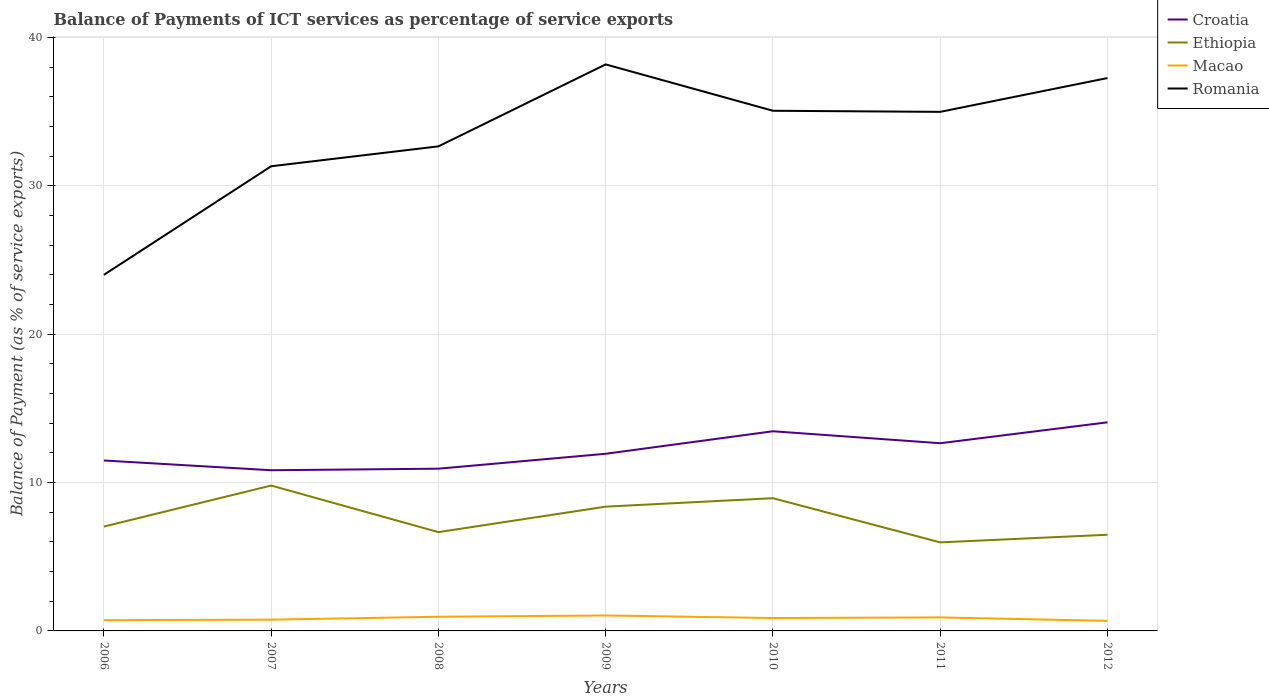How many different coloured lines are there?
Keep it short and to the point. 4. Does the line corresponding to Croatia intersect with the line corresponding to Romania?
Give a very brief answer. No. Across all years, what is the maximum balance of payments of ICT services in Ethiopia?
Make the answer very short. 5.97. What is the total balance of payments of ICT services in Croatia in the graph?
Provide a short and direct response. -0.71. What is the difference between the highest and the second highest balance of payments of ICT services in Macao?
Provide a succinct answer. 0.36. How many lines are there?
Your answer should be very brief. 4. How many years are there in the graph?
Ensure brevity in your answer.  7. What is the difference between two consecutive major ticks on the Y-axis?
Your answer should be compact. 10. Does the graph contain any zero values?
Keep it short and to the point. No. Does the graph contain grids?
Ensure brevity in your answer.  Yes. How are the legend labels stacked?
Provide a succinct answer. Vertical. What is the title of the graph?
Provide a short and direct response. Balance of Payments of ICT services as percentage of service exports. Does "Tanzania" appear as one of the legend labels in the graph?
Ensure brevity in your answer.  No. What is the label or title of the Y-axis?
Your answer should be very brief. Balance of Payment (as % of service exports). What is the Balance of Payment (as % of service exports) in Croatia in 2006?
Provide a short and direct response. 11.49. What is the Balance of Payment (as % of service exports) of Ethiopia in 2006?
Offer a terse response. 7.04. What is the Balance of Payment (as % of service exports) of Macao in 2006?
Offer a terse response. 0.72. What is the Balance of Payment (as % of service exports) in Romania in 2006?
Your response must be concise. 24.01. What is the Balance of Payment (as % of service exports) in Croatia in 2007?
Offer a terse response. 10.83. What is the Balance of Payment (as % of service exports) of Ethiopia in 2007?
Your response must be concise. 9.8. What is the Balance of Payment (as % of service exports) of Macao in 2007?
Provide a succinct answer. 0.76. What is the Balance of Payment (as % of service exports) of Romania in 2007?
Keep it short and to the point. 31.33. What is the Balance of Payment (as % of service exports) in Croatia in 2008?
Keep it short and to the point. 10.94. What is the Balance of Payment (as % of service exports) of Ethiopia in 2008?
Your answer should be compact. 6.66. What is the Balance of Payment (as % of service exports) of Macao in 2008?
Offer a very short reply. 0.96. What is the Balance of Payment (as % of service exports) of Romania in 2008?
Offer a very short reply. 32.67. What is the Balance of Payment (as % of service exports) in Croatia in 2009?
Provide a short and direct response. 11.94. What is the Balance of Payment (as % of service exports) of Ethiopia in 2009?
Keep it short and to the point. 8.38. What is the Balance of Payment (as % of service exports) in Macao in 2009?
Your answer should be very brief. 1.04. What is the Balance of Payment (as % of service exports) in Romania in 2009?
Make the answer very short. 38.2. What is the Balance of Payment (as % of service exports) in Croatia in 2010?
Give a very brief answer. 13.46. What is the Balance of Payment (as % of service exports) of Ethiopia in 2010?
Offer a very short reply. 8.95. What is the Balance of Payment (as % of service exports) of Macao in 2010?
Offer a terse response. 0.87. What is the Balance of Payment (as % of service exports) of Romania in 2010?
Make the answer very short. 35.07. What is the Balance of Payment (as % of service exports) in Croatia in 2011?
Give a very brief answer. 12.66. What is the Balance of Payment (as % of service exports) in Ethiopia in 2011?
Offer a terse response. 5.97. What is the Balance of Payment (as % of service exports) in Macao in 2011?
Your response must be concise. 0.91. What is the Balance of Payment (as % of service exports) in Romania in 2011?
Offer a terse response. 35. What is the Balance of Payment (as % of service exports) in Croatia in 2012?
Make the answer very short. 14.06. What is the Balance of Payment (as % of service exports) in Ethiopia in 2012?
Your answer should be compact. 6.48. What is the Balance of Payment (as % of service exports) of Macao in 2012?
Offer a very short reply. 0.68. What is the Balance of Payment (as % of service exports) of Romania in 2012?
Offer a terse response. 37.28. Across all years, what is the maximum Balance of Payment (as % of service exports) in Croatia?
Keep it short and to the point. 14.06. Across all years, what is the maximum Balance of Payment (as % of service exports) of Ethiopia?
Offer a terse response. 9.8. Across all years, what is the maximum Balance of Payment (as % of service exports) in Macao?
Provide a short and direct response. 1.04. Across all years, what is the maximum Balance of Payment (as % of service exports) of Romania?
Provide a short and direct response. 38.2. Across all years, what is the minimum Balance of Payment (as % of service exports) of Croatia?
Your response must be concise. 10.83. Across all years, what is the minimum Balance of Payment (as % of service exports) of Ethiopia?
Your answer should be very brief. 5.97. Across all years, what is the minimum Balance of Payment (as % of service exports) of Macao?
Ensure brevity in your answer.  0.68. Across all years, what is the minimum Balance of Payment (as % of service exports) in Romania?
Keep it short and to the point. 24.01. What is the total Balance of Payment (as % of service exports) of Croatia in the graph?
Your answer should be very brief. 85.39. What is the total Balance of Payment (as % of service exports) of Ethiopia in the graph?
Provide a succinct answer. 53.28. What is the total Balance of Payment (as % of service exports) of Macao in the graph?
Keep it short and to the point. 5.94. What is the total Balance of Payment (as % of service exports) of Romania in the graph?
Offer a terse response. 233.55. What is the difference between the Balance of Payment (as % of service exports) of Croatia in 2006 and that in 2007?
Provide a succinct answer. 0.66. What is the difference between the Balance of Payment (as % of service exports) of Ethiopia in 2006 and that in 2007?
Your answer should be very brief. -2.76. What is the difference between the Balance of Payment (as % of service exports) of Macao in 2006 and that in 2007?
Offer a terse response. -0.04. What is the difference between the Balance of Payment (as % of service exports) in Romania in 2006 and that in 2007?
Offer a very short reply. -7.32. What is the difference between the Balance of Payment (as % of service exports) of Croatia in 2006 and that in 2008?
Your answer should be compact. 0.55. What is the difference between the Balance of Payment (as % of service exports) in Ethiopia in 2006 and that in 2008?
Ensure brevity in your answer.  0.38. What is the difference between the Balance of Payment (as % of service exports) of Macao in 2006 and that in 2008?
Provide a succinct answer. -0.23. What is the difference between the Balance of Payment (as % of service exports) in Romania in 2006 and that in 2008?
Your response must be concise. -8.66. What is the difference between the Balance of Payment (as % of service exports) of Croatia in 2006 and that in 2009?
Offer a terse response. -0.45. What is the difference between the Balance of Payment (as % of service exports) in Ethiopia in 2006 and that in 2009?
Provide a succinct answer. -1.34. What is the difference between the Balance of Payment (as % of service exports) in Macao in 2006 and that in 2009?
Provide a succinct answer. -0.32. What is the difference between the Balance of Payment (as % of service exports) in Romania in 2006 and that in 2009?
Provide a short and direct response. -14.19. What is the difference between the Balance of Payment (as % of service exports) in Croatia in 2006 and that in 2010?
Ensure brevity in your answer.  -1.97. What is the difference between the Balance of Payment (as % of service exports) of Ethiopia in 2006 and that in 2010?
Your answer should be compact. -1.91. What is the difference between the Balance of Payment (as % of service exports) of Macao in 2006 and that in 2010?
Your response must be concise. -0.15. What is the difference between the Balance of Payment (as % of service exports) in Romania in 2006 and that in 2010?
Provide a short and direct response. -11.06. What is the difference between the Balance of Payment (as % of service exports) of Croatia in 2006 and that in 2011?
Offer a very short reply. -1.16. What is the difference between the Balance of Payment (as % of service exports) in Ethiopia in 2006 and that in 2011?
Your response must be concise. 1.07. What is the difference between the Balance of Payment (as % of service exports) in Macao in 2006 and that in 2011?
Your response must be concise. -0.19. What is the difference between the Balance of Payment (as % of service exports) of Romania in 2006 and that in 2011?
Give a very brief answer. -10.99. What is the difference between the Balance of Payment (as % of service exports) of Croatia in 2006 and that in 2012?
Provide a short and direct response. -2.57. What is the difference between the Balance of Payment (as % of service exports) in Ethiopia in 2006 and that in 2012?
Offer a terse response. 0.55. What is the difference between the Balance of Payment (as % of service exports) of Macao in 2006 and that in 2012?
Give a very brief answer. 0.05. What is the difference between the Balance of Payment (as % of service exports) in Romania in 2006 and that in 2012?
Provide a short and direct response. -13.27. What is the difference between the Balance of Payment (as % of service exports) of Croatia in 2007 and that in 2008?
Your response must be concise. -0.1. What is the difference between the Balance of Payment (as % of service exports) in Ethiopia in 2007 and that in 2008?
Your response must be concise. 3.14. What is the difference between the Balance of Payment (as % of service exports) in Macao in 2007 and that in 2008?
Your answer should be very brief. -0.2. What is the difference between the Balance of Payment (as % of service exports) in Romania in 2007 and that in 2008?
Provide a succinct answer. -1.34. What is the difference between the Balance of Payment (as % of service exports) in Croatia in 2007 and that in 2009?
Your answer should be compact. -1.11. What is the difference between the Balance of Payment (as % of service exports) in Ethiopia in 2007 and that in 2009?
Provide a succinct answer. 1.42. What is the difference between the Balance of Payment (as % of service exports) in Macao in 2007 and that in 2009?
Keep it short and to the point. -0.28. What is the difference between the Balance of Payment (as % of service exports) of Romania in 2007 and that in 2009?
Provide a short and direct response. -6.87. What is the difference between the Balance of Payment (as % of service exports) of Croatia in 2007 and that in 2010?
Ensure brevity in your answer.  -2.63. What is the difference between the Balance of Payment (as % of service exports) in Ethiopia in 2007 and that in 2010?
Ensure brevity in your answer.  0.85. What is the difference between the Balance of Payment (as % of service exports) in Macao in 2007 and that in 2010?
Keep it short and to the point. -0.11. What is the difference between the Balance of Payment (as % of service exports) in Romania in 2007 and that in 2010?
Offer a very short reply. -3.74. What is the difference between the Balance of Payment (as % of service exports) in Croatia in 2007 and that in 2011?
Provide a succinct answer. -1.82. What is the difference between the Balance of Payment (as % of service exports) of Ethiopia in 2007 and that in 2011?
Your answer should be very brief. 3.83. What is the difference between the Balance of Payment (as % of service exports) in Macao in 2007 and that in 2011?
Make the answer very short. -0.15. What is the difference between the Balance of Payment (as % of service exports) in Romania in 2007 and that in 2011?
Make the answer very short. -3.67. What is the difference between the Balance of Payment (as % of service exports) in Croatia in 2007 and that in 2012?
Give a very brief answer. -3.23. What is the difference between the Balance of Payment (as % of service exports) of Ethiopia in 2007 and that in 2012?
Your response must be concise. 3.32. What is the difference between the Balance of Payment (as % of service exports) in Macao in 2007 and that in 2012?
Offer a terse response. 0.08. What is the difference between the Balance of Payment (as % of service exports) in Romania in 2007 and that in 2012?
Provide a short and direct response. -5.95. What is the difference between the Balance of Payment (as % of service exports) of Croatia in 2008 and that in 2009?
Ensure brevity in your answer.  -1.01. What is the difference between the Balance of Payment (as % of service exports) of Ethiopia in 2008 and that in 2009?
Keep it short and to the point. -1.72. What is the difference between the Balance of Payment (as % of service exports) in Macao in 2008 and that in 2009?
Offer a terse response. -0.09. What is the difference between the Balance of Payment (as % of service exports) of Romania in 2008 and that in 2009?
Offer a very short reply. -5.53. What is the difference between the Balance of Payment (as % of service exports) in Croatia in 2008 and that in 2010?
Offer a terse response. -2.52. What is the difference between the Balance of Payment (as % of service exports) in Ethiopia in 2008 and that in 2010?
Make the answer very short. -2.29. What is the difference between the Balance of Payment (as % of service exports) in Macao in 2008 and that in 2010?
Offer a terse response. 0.09. What is the difference between the Balance of Payment (as % of service exports) in Romania in 2008 and that in 2010?
Your response must be concise. -2.4. What is the difference between the Balance of Payment (as % of service exports) in Croatia in 2008 and that in 2011?
Your answer should be very brief. -1.72. What is the difference between the Balance of Payment (as % of service exports) in Ethiopia in 2008 and that in 2011?
Offer a very short reply. 0.69. What is the difference between the Balance of Payment (as % of service exports) in Macao in 2008 and that in 2011?
Your response must be concise. 0.04. What is the difference between the Balance of Payment (as % of service exports) of Romania in 2008 and that in 2011?
Keep it short and to the point. -2.33. What is the difference between the Balance of Payment (as % of service exports) in Croatia in 2008 and that in 2012?
Your answer should be compact. -3.13. What is the difference between the Balance of Payment (as % of service exports) in Ethiopia in 2008 and that in 2012?
Offer a terse response. 0.18. What is the difference between the Balance of Payment (as % of service exports) of Macao in 2008 and that in 2012?
Your answer should be very brief. 0.28. What is the difference between the Balance of Payment (as % of service exports) in Romania in 2008 and that in 2012?
Keep it short and to the point. -4.61. What is the difference between the Balance of Payment (as % of service exports) in Croatia in 2009 and that in 2010?
Your response must be concise. -1.52. What is the difference between the Balance of Payment (as % of service exports) of Ethiopia in 2009 and that in 2010?
Offer a very short reply. -0.57. What is the difference between the Balance of Payment (as % of service exports) of Macao in 2009 and that in 2010?
Your answer should be very brief. 0.17. What is the difference between the Balance of Payment (as % of service exports) of Romania in 2009 and that in 2010?
Offer a very short reply. 3.13. What is the difference between the Balance of Payment (as % of service exports) in Croatia in 2009 and that in 2011?
Provide a short and direct response. -0.71. What is the difference between the Balance of Payment (as % of service exports) of Ethiopia in 2009 and that in 2011?
Ensure brevity in your answer.  2.41. What is the difference between the Balance of Payment (as % of service exports) of Macao in 2009 and that in 2011?
Keep it short and to the point. 0.13. What is the difference between the Balance of Payment (as % of service exports) in Romania in 2009 and that in 2011?
Ensure brevity in your answer.  3.2. What is the difference between the Balance of Payment (as % of service exports) in Croatia in 2009 and that in 2012?
Keep it short and to the point. -2.12. What is the difference between the Balance of Payment (as % of service exports) in Ethiopia in 2009 and that in 2012?
Ensure brevity in your answer.  1.89. What is the difference between the Balance of Payment (as % of service exports) in Macao in 2009 and that in 2012?
Give a very brief answer. 0.36. What is the difference between the Balance of Payment (as % of service exports) of Romania in 2009 and that in 2012?
Make the answer very short. 0.92. What is the difference between the Balance of Payment (as % of service exports) in Croatia in 2010 and that in 2011?
Your response must be concise. 0.81. What is the difference between the Balance of Payment (as % of service exports) in Ethiopia in 2010 and that in 2011?
Your answer should be very brief. 2.98. What is the difference between the Balance of Payment (as % of service exports) of Macao in 2010 and that in 2011?
Your response must be concise. -0.04. What is the difference between the Balance of Payment (as % of service exports) in Romania in 2010 and that in 2011?
Provide a short and direct response. 0.07. What is the difference between the Balance of Payment (as % of service exports) in Croatia in 2010 and that in 2012?
Offer a very short reply. -0.6. What is the difference between the Balance of Payment (as % of service exports) of Ethiopia in 2010 and that in 2012?
Give a very brief answer. 2.46. What is the difference between the Balance of Payment (as % of service exports) of Macao in 2010 and that in 2012?
Provide a short and direct response. 0.19. What is the difference between the Balance of Payment (as % of service exports) in Romania in 2010 and that in 2012?
Your response must be concise. -2.21. What is the difference between the Balance of Payment (as % of service exports) in Croatia in 2011 and that in 2012?
Provide a short and direct response. -1.41. What is the difference between the Balance of Payment (as % of service exports) in Ethiopia in 2011 and that in 2012?
Offer a very short reply. -0.51. What is the difference between the Balance of Payment (as % of service exports) of Macao in 2011 and that in 2012?
Provide a succinct answer. 0.23. What is the difference between the Balance of Payment (as % of service exports) in Romania in 2011 and that in 2012?
Your answer should be compact. -2.28. What is the difference between the Balance of Payment (as % of service exports) of Croatia in 2006 and the Balance of Payment (as % of service exports) of Ethiopia in 2007?
Give a very brief answer. 1.69. What is the difference between the Balance of Payment (as % of service exports) of Croatia in 2006 and the Balance of Payment (as % of service exports) of Macao in 2007?
Provide a short and direct response. 10.73. What is the difference between the Balance of Payment (as % of service exports) of Croatia in 2006 and the Balance of Payment (as % of service exports) of Romania in 2007?
Give a very brief answer. -19.84. What is the difference between the Balance of Payment (as % of service exports) of Ethiopia in 2006 and the Balance of Payment (as % of service exports) of Macao in 2007?
Your answer should be very brief. 6.28. What is the difference between the Balance of Payment (as % of service exports) of Ethiopia in 2006 and the Balance of Payment (as % of service exports) of Romania in 2007?
Offer a terse response. -24.29. What is the difference between the Balance of Payment (as % of service exports) of Macao in 2006 and the Balance of Payment (as % of service exports) of Romania in 2007?
Your answer should be compact. -30.61. What is the difference between the Balance of Payment (as % of service exports) of Croatia in 2006 and the Balance of Payment (as % of service exports) of Ethiopia in 2008?
Provide a succinct answer. 4.83. What is the difference between the Balance of Payment (as % of service exports) in Croatia in 2006 and the Balance of Payment (as % of service exports) in Macao in 2008?
Your answer should be very brief. 10.54. What is the difference between the Balance of Payment (as % of service exports) in Croatia in 2006 and the Balance of Payment (as % of service exports) in Romania in 2008?
Provide a short and direct response. -21.18. What is the difference between the Balance of Payment (as % of service exports) of Ethiopia in 2006 and the Balance of Payment (as % of service exports) of Macao in 2008?
Offer a very short reply. 6.08. What is the difference between the Balance of Payment (as % of service exports) of Ethiopia in 2006 and the Balance of Payment (as % of service exports) of Romania in 2008?
Make the answer very short. -25.63. What is the difference between the Balance of Payment (as % of service exports) in Macao in 2006 and the Balance of Payment (as % of service exports) in Romania in 2008?
Your answer should be very brief. -31.95. What is the difference between the Balance of Payment (as % of service exports) in Croatia in 2006 and the Balance of Payment (as % of service exports) in Ethiopia in 2009?
Provide a short and direct response. 3.11. What is the difference between the Balance of Payment (as % of service exports) of Croatia in 2006 and the Balance of Payment (as % of service exports) of Macao in 2009?
Your answer should be compact. 10.45. What is the difference between the Balance of Payment (as % of service exports) of Croatia in 2006 and the Balance of Payment (as % of service exports) of Romania in 2009?
Make the answer very short. -26.71. What is the difference between the Balance of Payment (as % of service exports) in Ethiopia in 2006 and the Balance of Payment (as % of service exports) in Macao in 2009?
Offer a terse response. 5.99. What is the difference between the Balance of Payment (as % of service exports) of Ethiopia in 2006 and the Balance of Payment (as % of service exports) of Romania in 2009?
Your answer should be very brief. -31.16. What is the difference between the Balance of Payment (as % of service exports) in Macao in 2006 and the Balance of Payment (as % of service exports) in Romania in 2009?
Keep it short and to the point. -37.47. What is the difference between the Balance of Payment (as % of service exports) in Croatia in 2006 and the Balance of Payment (as % of service exports) in Ethiopia in 2010?
Give a very brief answer. 2.54. What is the difference between the Balance of Payment (as % of service exports) in Croatia in 2006 and the Balance of Payment (as % of service exports) in Macao in 2010?
Offer a very short reply. 10.62. What is the difference between the Balance of Payment (as % of service exports) of Croatia in 2006 and the Balance of Payment (as % of service exports) of Romania in 2010?
Your response must be concise. -23.58. What is the difference between the Balance of Payment (as % of service exports) of Ethiopia in 2006 and the Balance of Payment (as % of service exports) of Macao in 2010?
Your response must be concise. 6.17. What is the difference between the Balance of Payment (as % of service exports) of Ethiopia in 2006 and the Balance of Payment (as % of service exports) of Romania in 2010?
Your answer should be compact. -28.03. What is the difference between the Balance of Payment (as % of service exports) in Macao in 2006 and the Balance of Payment (as % of service exports) in Romania in 2010?
Make the answer very short. -34.35. What is the difference between the Balance of Payment (as % of service exports) of Croatia in 2006 and the Balance of Payment (as % of service exports) of Ethiopia in 2011?
Offer a very short reply. 5.52. What is the difference between the Balance of Payment (as % of service exports) in Croatia in 2006 and the Balance of Payment (as % of service exports) in Macao in 2011?
Provide a short and direct response. 10.58. What is the difference between the Balance of Payment (as % of service exports) of Croatia in 2006 and the Balance of Payment (as % of service exports) of Romania in 2011?
Give a very brief answer. -23.51. What is the difference between the Balance of Payment (as % of service exports) of Ethiopia in 2006 and the Balance of Payment (as % of service exports) of Macao in 2011?
Provide a short and direct response. 6.13. What is the difference between the Balance of Payment (as % of service exports) of Ethiopia in 2006 and the Balance of Payment (as % of service exports) of Romania in 2011?
Ensure brevity in your answer.  -27.96. What is the difference between the Balance of Payment (as % of service exports) in Macao in 2006 and the Balance of Payment (as % of service exports) in Romania in 2011?
Your answer should be compact. -34.27. What is the difference between the Balance of Payment (as % of service exports) of Croatia in 2006 and the Balance of Payment (as % of service exports) of Ethiopia in 2012?
Your response must be concise. 5.01. What is the difference between the Balance of Payment (as % of service exports) of Croatia in 2006 and the Balance of Payment (as % of service exports) of Macao in 2012?
Ensure brevity in your answer.  10.81. What is the difference between the Balance of Payment (as % of service exports) in Croatia in 2006 and the Balance of Payment (as % of service exports) in Romania in 2012?
Provide a succinct answer. -25.79. What is the difference between the Balance of Payment (as % of service exports) in Ethiopia in 2006 and the Balance of Payment (as % of service exports) in Macao in 2012?
Your answer should be compact. 6.36. What is the difference between the Balance of Payment (as % of service exports) in Ethiopia in 2006 and the Balance of Payment (as % of service exports) in Romania in 2012?
Offer a terse response. -30.24. What is the difference between the Balance of Payment (as % of service exports) in Macao in 2006 and the Balance of Payment (as % of service exports) in Romania in 2012?
Your answer should be compact. -36.55. What is the difference between the Balance of Payment (as % of service exports) of Croatia in 2007 and the Balance of Payment (as % of service exports) of Ethiopia in 2008?
Your answer should be very brief. 4.17. What is the difference between the Balance of Payment (as % of service exports) of Croatia in 2007 and the Balance of Payment (as % of service exports) of Macao in 2008?
Your response must be concise. 9.88. What is the difference between the Balance of Payment (as % of service exports) in Croatia in 2007 and the Balance of Payment (as % of service exports) in Romania in 2008?
Your answer should be very brief. -21.84. What is the difference between the Balance of Payment (as % of service exports) in Ethiopia in 2007 and the Balance of Payment (as % of service exports) in Macao in 2008?
Give a very brief answer. 8.85. What is the difference between the Balance of Payment (as % of service exports) in Ethiopia in 2007 and the Balance of Payment (as % of service exports) in Romania in 2008?
Your answer should be very brief. -22.87. What is the difference between the Balance of Payment (as % of service exports) of Macao in 2007 and the Balance of Payment (as % of service exports) of Romania in 2008?
Your answer should be very brief. -31.91. What is the difference between the Balance of Payment (as % of service exports) in Croatia in 2007 and the Balance of Payment (as % of service exports) in Ethiopia in 2009?
Make the answer very short. 2.46. What is the difference between the Balance of Payment (as % of service exports) in Croatia in 2007 and the Balance of Payment (as % of service exports) in Macao in 2009?
Your answer should be very brief. 9.79. What is the difference between the Balance of Payment (as % of service exports) in Croatia in 2007 and the Balance of Payment (as % of service exports) in Romania in 2009?
Your answer should be compact. -27.36. What is the difference between the Balance of Payment (as % of service exports) of Ethiopia in 2007 and the Balance of Payment (as % of service exports) of Macao in 2009?
Offer a terse response. 8.76. What is the difference between the Balance of Payment (as % of service exports) of Ethiopia in 2007 and the Balance of Payment (as % of service exports) of Romania in 2009?
Your response must be concise. -28.39. What is the difference between the Balance of Payment (as % of service exports) of Macao in 2007 and the Balance of Payment (as % of service exports) of Romania in 2009?
Your answer should be very brief. -37.44. What is the difference between the Balance of Payment (as % of service exports) in Croatia in 2007 and the Balance of Payment (as % of service exports) in Ethiopia in 2010?
Ensure brevity in your answer.  1.89. What is the difference between the Balance of Payment (as % of service exports) of Croatia in 2007 and the Balance of Payment (as % of service exports) of Macao in 2010?
Your response must be concise. 9.97. What is the difference between the Balance of Payment (as % of service exports) of Croatia in 2007 and the Balance of Payment (as % of service exports) of Romania in 2010?
Your answer should be very brief. -24.24. What is the difference between the Balance of Payment (as % of service exports) of Ethiopia in 2007 and the Balance of Payment (as % of service exports) of Macao in 2010?
Give a very brief answer. 8.93. What is the difference between the Balance of Payment (as % of service exports) of Ethiopia in 2007 and the Balance of Payment (as % of service exports) of Romania in 2010?
Keep it short and to the point. -25.27. What is the difference between the Balance of Payment (as % of service exports) in Macao in 2007 and the Balance of Payment (as % of service exports) in Romania in 2010?
Keep it short and to the point. -34.31. What is the difference between the Balance of Payment (as % of service exports) of Croatia in 2007 and the Balance of Payment (as % of service exports) of Ethiopia in 2011?
Make the answer very short. 4.86. What is the difference between the Balance of Payment (as % of service exports) in Croatia in 2007 and the Balance of Payment (as % of service exports) in Macao in 2011?
Make the answer very short. 9.92. What is the difference between the Balance of Payment (as % of service exports) in Croatia in 2007 and the Balance of Payment (as % of service exports) in Romania in 2011?
Provide a succinct answer. -24.16. What is the difference between the Balance of Payment (as % of service exports) in Ethiopia in 2007 and the Balance of Payment (as % of service exports) in Macao in 2011?
Provide a short and direct response. 8.89. What is the difference between the Balance of Payment (as % of service exports) in Ethiopia in 2007 and the Balance of Payment (as % of service exports) in Romania in 2011?
Your answer should be compact. -25.2. What is the difference between the Balance of Payment (as % of service exports) in Macao in 2007 and the Balance of Payment (as % of service exports) in Romania in 2011?
Your answer should be compact. -34.24. What is the difference between the Balance of Payment (as % of service exports) in Croatia in 2007 and the Balance of Payment (as % of service exports) in Ethiopia in 2012?
Keep it short and to the point. 4.35. What is the difference between the Balance of Payment (as % of service exports) in Croatia in 2007 and the Balance of Payment (as % of service exports) in Macao in 2012?
Ensure brevity in your answer.  10.16. What is the difference between the Balance of Payment (as % of service exports) in Croatia in 2007 and the Balance of Payment (as % of service exports) in Romania in 2012?
Your answer should be very brief. -26.44. What is the difference between the Balance of Payment (as % of service exports) of Ethiopia in 2007 and the Balance of Payment (as % of service exports) of Macao in 2012?
Provide a succinct answer. 9.12. What is the difference between the Balance of Payment (as % of service exports) in Ethiopia in 2007 and the Balance of Payment (as % of service exports) in Romania in 2012?
Your response must be concise. -27.47. What is the difference between the Balance of Payment (as % of service exports) of Macao in 2007 and the Balance of Payment (as % of service exports) of Romania in 2012?
Your answer should be compact. -36.52. What is the difference between the Balance of Payment (as % of service exports) in Croatia in 2008 and the Balance of Payment (as % of service exports) in Ethiopia in 2009?
Your response must be concise. 2.56. What is the difference between the Balance of Payment (as % of service exports) in Croatia in 2008 and the Balance of Payment (as % of service exports) in Macao in 2009?
Provide a short and direct response. 9.89. What is the difference between the Balance of Payment (as % of service exports) of Croatia in 2008 and the Balance of Payment (as % of service exports) of Romania in 2009?
Ensure brevity in your answer.  -27.26. What is the difference between the Balance of Payment (as % of service exports) of Ethiopia in 2008 and the Balance of Payment (as % of service exports) of Macao in 2009?
Make the answer very short. 5.62. What is the difference between the Balance of Payment (as % of service exports) in Ethiopia in 2008 and the Balance of Payment (as % of service exports) in Romania in 2009?
Keep it short and to the point. -31.54. What is the difference between the Balance of Payment (as % of service exports) of Macao in 2008 and the Balance of Payment (as % of service exports) of Romania in 2009?
Your response must be concise. -37.24. What is the difference between the Balance of Payment (as % of service exports) in Croatia in 2008 and the Balance of Payment (as % of service exports) in Ethiopia in 2010?
Make the answer very short. 1.99. What is the difference between the Balance of Payment (as % of service exports) in Croatia in 2008 and the Balance of Payment (as % of service exports) in Macao in 2010?
Ensure brevity in your answer.  10.07. What is the difference between the Balance of Payment (as % of service exports) of Croatia in 2008 and the Balance of Payment (as % of service exports) of Romania in 2010?
Your answer should be compact. -24.13. What is the difference between the Balance of Payment (as % of service exports) in Ethiopia in 2008 and the Balance of Payment (as % of service exports) in Macao in 2010?
Your answer should be compact. 5.79. What is the difference between the Balance of Payment (as % of service exports) of Ethiopia in 2008 and the Balance of Payment (as % of service exports) of Romania in 2010?
Your answer should be compact. -28.41. What is the difference between the Balance of Payment (as % of service exports) of Macao in 2008 and the Balance of Payment (as % of service exports) of Romania in 2010?
Offer a terse response. -34.11. What is the difference between the Balance of Payment (as % of service exports) in Croatia in 2008 and the Balance of Payment (as % of service exports) in Ethiopia in 2011?
Give a very brief answer. 4.97. What is the difference between the Balance of Payment (as % of service exports) in Croatia in 2008 and the Balance of Payment (as % of service exports) in Macao in 2011?
Provide a short and direct response. 10.03. What is the difference between the Balance of Payment (as % of service exports) of Croatia in 2008 and the Balance of Payment (as % of service exports) of Romania in 2011?
Your answer should be compact. -24.06. What is the difference between the Balance of Payment (as % of service exports) of Ethiopia in 2008 and the Balance of Payment (as % of service exports) of Macao in 2011?
Your answer should be compact. 5.75. What is the difference between the Balance of Payment (as % of service exports) of Ethiopia in 2008 and the Balance of Payment (as % of service exports) of Romania in 2011?
Offer a terse response. -28.34. What is the difference between the Balance of Payment (as % of service exports) in Macao in 2008 and the Balance of Payment (as % of service exports) in Romania in 2011?
Offer a very short reply. -34.04. What is the difference between the Balance of Payment (as % of service exports) of Croatia in 2008 and the Balance of Payment (as % of service exports) of Ethiopia in 2012?
Provide a short and direct response. 4.45. What is the difference between the Balance of Payment (as % of service exports) in Croatia in 2008 and the Balance of Payment (as % of service exports) in Macao in 2012?
Make the answer very short. 10.26. What is the difference between the Balance of Payment (as % of service exports) of Croatia in 2008 and the Balance of Payment (as % of service exports) of Romania in 2012?
Ensure brevity in your answer.  -26.34. What is the difference between the Balance of Payment (as % of service exports) in Ethiopia in 2008 and the Balance of Payment (as % of service exports) in Macao in 2012?
Your answer should be very brief. 5.98. What is the difference between the Balance of Payment (as % of service exports) of Ethiopia in 2008 and the Balance of Payment (as % of service exports) of Romania in 2012?
Provide a succinct answer. -30.62. What is the difference between the Balance of Payment (as % of service exports) of Macao in 2008 and the Balance of Payment (as % of service exports) of Romania in 2012?
Your answer should be very brief. -36.32. What is the difference between the Balance of Payment (as % of service exports) in Croatia in 2009 and the Balance of Payment (as % of service exports) in Ethiopia in 2010?
Your answer should be very brief. 3. What is the difference between the Balance of Payment (as % of service exports) of Croatia in 2009 and the Balance of Payment (as % of service exports) of Macao in 2010?
Your answer should be very brief. 11.08. What is the difference between the Balance of Payment (as % of service exports) of Croatia in 2009 and the Balance of Payment (as % of service exports) of Romania in 2010?
Provide a succinct answer. -23.13. What is the difference between the Balance of Payment (as % of service exports) of Ethiopia in 2009 and the Balance of Payment (as % of service exports) of Macao in 2010?
Keep it short and to the point. 7.51. What is the difference between the Balance of Payment (as % of service exports) in Ethiopia in 2009 and the Balance of Payment (as % of service exports) in Romania in 2010?
Provide a short and direct response. -26.69. What is the difference between the Balance of Payment (as % of service exports) in Macao in 2009 and the Balance of Payment (as % of service exports) in Romania in 2010?
Make the answer very short. -34.03. What is the difference between the Balance of Payment (as % of service exports) in Croatia in 2009 and the Balance of Payment (as % of service exports) in Ethiopia in 2011?
Your answer should be very brief. 5.97. What is the difference between the Balance of Payment (as % of service exports) in Croatia in 2009 and the Balance of Payment (as % of service exports) in Macao in 2011?
Provide a short and direct response. 11.03. What is the difference between the Balance of Payment (as % of service exports) of Croatia in 2009 and the Balance of Payment (as % of service exports) of Romania in 2011?
Your answer should be compact. -23.05. What is the difference between the Balance of Payment (as % of service exports) in Ethiopia in 2009 and the Balance of Payment (as % of service exports) in Macao in 2011?
Provide a short and direct response. 7.47. What is the difference between the Balance of Payment (as % of service exports) in Ethiopia in 2009 and the Balance of Payment (as % of service exports) in Romania in 2011?
Your response must be concise. -26.62. What is the difference between the Balance of Payment (as % of service exports) of Macao in 2009 and the Balance of Payment (as % of service exports) of Romania in 2011?
Offer a terse response. -33.95. What is the difference between the Balance of Payment (as % of service exports) of Croatia in 2009 and the Balance of Payment (as % of service exports) of Ethiopia in 2012?
Offer a very short reply. 5.46. What is the difference between the Balance of Payment (as % of service exports) of Croatia in 2009 and the Balance of Payment (as % of service exports) of Macao in 2012?
Keep it short and to the point. 11.27. What is the difference between the Balance of Payment (as % of service exports) in Croatia in 2009 and the Balance of Payment (as % of service exports) in Romania in 2012?
Offer a terse response. -25.33. What is the difference between the Balance of Payment (as % of service exports) of Ethiopia in 2009 and the Balance of Payment (as % of service exports) of Romania in 2012?
Provide a short and direct response. -28.9. What is the difference between the Balance of Payment (as % of service exports) in Macao in 2009 and the Balance of Payment (as % of service exports) in Romania in 2012?
Provide a succinct answer. -36.23. What is the difference between the Balance of Payment (as % of service exports) of Croatia in 2010 and the Balance of Payment (as % of service exports) of Ethiopia in 2011?
Give a very brief answer. 7.49. What is the difference between the Balance of Payment (as % of service exports) in Croatia in 2010 and the Balance of Payment (as % of service exports) in Macao in 2011?
Keep it short and to the point. 12.55. What is the difference between the Balance of Payment (as % of service exports) of Croatia in 2010 and the Balance of Payment (as % of service exports) of Romania in 2011?
Give a very brief answer. -21.54. What is the difference between the Balance of Payment (as % of service exports) of Ethiopia in 2010 and the Balance of Payment (as % of service exports) of Macao in 2011?
Offer a terse response. 8.04. What is the difference between the Balance of Payment (as % of service exports) in Ethiopia in 2010 and the Balance of Payment (as % of service exports) in Romania in 2011?
Your answer should be compact. -26.05. What is the difference between the Balance of Payment (as % of service exports) in Macao in 2010 and the Balance of Payment (as % of service exports) in Romania in 2011?
Provide a short and direct response. -34.13. What is the difference between the Balance of Payment (as % of service exports) in Croatia in 2010 and the Balance of Payment (as % of service exports) in Ethiopia in 2012?
Ensure brevity in your answer.  6.98. What is the difference between the Balance of Payment (as % of service exports) of Croatia in 2010 and the Balance of Payment (as % of service exports) of Macao in 2012?
Provide a succinct answer. 12.78. What is the difference between the Balance of Payment (as % of service exports) of Croatia in 2010 and the Balance of Payment (as % of service exports) of Romania in 2012?
Your answer should be compact. -23.81. What is the difference between the Balance of Payment (as % of service exports) in Ethiopia in 2010 and the Balance of Payment (as % of service exports) in Macao in 2012?
Your answer should be very brief. 8.27. What is the difference between the Balance of Payment (as % of service exports) in Ethiopia in 2010 and the Balance of Payment (as % of service exports) in Romania in 2012?
Give a very brief answer. -28.33. What is the difference between the Balance of Payment (as % of service exports) of Macao in 2010 and the Balance of Payment (as % of service exports) of Romania in 2012?
Your answer should be very brief. -36.41. What is the difference between the Balance of Payment (as % of service exports) of Croatia in 2011 and the Balance of Payment (as % of service exports) of Ethiopia in 2012?
Ensure brevity in your answer.  6.17. What is the difference between the Balance of Payment (as % of service exports) in Croatia in 2011 and the Balance of Payment (as % of service exports) in Macao in 2012?
Provide a short and direct response. 11.98. What is the difference between the Balance of Payment (as % of service exports) of Croatia in 2011 and the Balance of Payment (as % of service exports) of Romania in 2012?
Offer a terse response. -24.62. What is the difference between the Balance of Payment (as % of service exports) of Ethiopia in 2011 and the Balance of Payment (as % of service exports) of Macao in 2012?
Provide a short and direct response. 5.29. What is the difference between the Balance of Payment (as % of service exports) in Ethiopia in 2011 and the Balance of Payment (as % of service exports) in Romania in 2012?
Provide a succinct answer. -31.31. What is the difference between the Balance of Payment (as % of service exports) of Macao in 2011 and the Balance of Payment (as % of service exports) of Romania in 2012?
Give a very brief answer. -36.37. What is the average Balance of Payment (as % of service exports) of Croatia per year?
Your answer should be very brief. 12.2. What is the average Balance of Payment (as % of service exports) in Ethiopia per year?
Your answer should be compact. 7.61. What is the average Balance of Payment (as % of service exports) of Macao per year?
Provide a short and direct response. 0.85. What is the average Balance of Payment (as % of service exports) of Romania per year?
Provide a succinct answer. 33.36. In the year 2006, what is the difference between the Balance of Payment (as % of service exports) of Croatia and Balance of Payment (as % of service exports) of Ethiopia?
Provide a short and direct response. 4.45. In the year 2006, what is the difference between the Balance of Payment (as % of service exports) of Croatia and Balance of Payment (as % of service exports) of Macao?
Offer a terse response. 10.77. In the year 2006, what is the difference between the Balance of Payment (as % of service exports) of Croatia and Balance of Payment (as % of service exports) of Romania?
Give a very brief answer. -12.52. In the year 2006, what is the difference between the Balance of Payment (as % of service exports) in Ethiopia and Balance of Payment (as % of service exports) in Macao?
Provide a succinct answer. 6.31. In the year 2006, what is the difference between the Balance of Payment (as % of service exports) in Ethiopia and Balance of Payment (as % of service exports) in Romania?
Keep it short and to the point. -16.97. In the year 2006, what is the difference between the Balance of Payment (as % of service exports) in Macao and Balance of Payment (as % of service exports) in Romania?
Your response must be concise. -23.28. In the year 2007, what is the difference between the Balance of Payment (as % of service exports) of Croatia and Balance of Payment (as % of service exports) of Ethiopia?
Provide a short and direct response. 1.03. In the year 2007, what is the difference between the Balance of Payment (as % of service exports) in Croatia and Balance of Payment (as % of service exports) in Macao?
Make the answer very short. 10.08. In the year 2007, what is the difference between the Balance of Payment (as % of service exports) in Croatia and Balance of Payment (as % of service exports) in Romania?
Your answer should be compact. -20.49. In the year 2007, what is the difference between the Balance of Payment (as % of service exports) in Ethiopia and Balance of Payment (as % of service exports) in Macao?
Give a very brief answer. 9.04. In the year 2007, what is the difference between the Balance of Payment (as % of service exports) in Ethiopia and Balance of Payment (as % of service exports) in Romania?
Provide a succinct answer. -21.53. In the year 2007, what is the difference between the Balance of Payment (as % of service exports) of Macao and Balance of Payment (as % of service exports) of Romania?
Provide a short and direct response. -30.57. In the year 2008, what is the difference between the Balance of Payment (as % of service exports) of Croatia and Balance of Payment (as % of service exports) of Ethiopia?
Your response must be concise. 4.28. In the year 2008, what is the difference between the Balance of Payment (as % of service exports) of Croatia and Balance of Payment (as % of service exports) of Macao?
Your response must be concise. 9.98. In the year 2008, what is the difference between the Balance of Payment (as % of service exports) in Croatia and Balance of Payment (as % of service exports) in Romania?
Offer a very short reply. -21.73. In the year 2008, what is the difference between the Balance of Payment (as % of service exports) of Ethiopia and Balance of Payment (as % of service exports) of Macao?
Your answer should be very brief. 5.7. In the year 2008, what is the difference between the Balance of Payment (as % of service exports) in Ethiopia and Balance of Payment (as % of service exports) in Romania?
Provide a short and direct response. -26.01. In the year 2008, what is the difference between the Balance of Payment (as % of service exports) of Macao and Balance of Payment (as % of service exports) of Romania?
Your answer should be compact. -31.71. In the year 2009, what is the difference between the Balance of Payment (as % of service exports) of Croatia and Balance of Payment (as % of service exports) of Ethiopia?
Offer a terse response. 3.57. In the year 2009, what is the difference between the Balance of Payment (as % of service exports) in Croatia and Balance of Payment (as % of service exports) in Macao?
Provide a short and direct response. 10.9. In the year 2009, what is the difference between the Balance of Payment (as % of service exports) in Croatia and Balance of Payment (as % of service exports) in Romania?
Make the answer very short. -26.25. In the year 2009, what is the difference between the Balance of Payment (as % of service exports) of Ethiopia and Balance of Payment (as % of service exports) of Macao?
Your answer should be very brief. 7.34. In the year 2009, what is the difference between the Balance of Payment (as % of service exports) of Ethiopia and Balance of Payment (as % of service exports) of Romania?
Make the answer very short. -29.82. In the year 2009, what is the difference between the Balance of Payment (as % of service exports) of Macao and Balance of Payment (as % of service exports) of Romania?
Offer a terse response. -37.15. In the year 2010, what is the difference between the Balance of Payment (as % of service exports) of Croatia and Balance of Payment (as % of service exports) of Ethiopia?
Your response must be concise. 4.51. In the year 2010, what is the difference between the Balance of Payment (as % of service exports) of Croatia and Balance of Payment (as % of service exports) of Macao?
Your answer should be compact. 12.59. In the year 2010, what is the difference between the Balance of Payment (as % of service exports) of Croatia and Balance of Payment (as % of service exports) of Romania?
Give a very brief answer. -21.61. In the year 2010, what is the difference between the Balance of Payment (as % of service exports) in Ethiopia and Balance of Payment (as % of service exports) in Macao?
Provide a succinct answer. 8.08. In the year 2010, what is the difference between the Balance of Payment (as % of service exports) in Ethiopia and Balance of Payment (as % of service exports) in Romania?
Your response must be concise. -26.12. In the year 2010, what is the difference between the Balance of Payment (as % of service exports) in Macao and Balance of Payment (as % of service exports) in Romania?
Keep it short and to the point. -34.2. In the year 2011, what is the difference between the Balance of Payment (as % of service exports) of Croatia and Balance of Payment (as % of service exports) of Ethiopia?
Your response must be concise. 6.68. In the year 2011, what is the difference between the Balance of Payment (as % of service exports) of Croatia and Balance of Payment (as % of service exports) of Macao?
Your answer should be very brief. 11.74. In the year 2011, what is the difference between the Balance of Payment (as % of service exports) of Croatia and Balance of Payment (as % of service exports) of Romania?
Provide a short and direct response. -22.34. In the year 2011, what is the difference between the Balance of Payment (as % of service exports) in Ethiopia and Balance of Payment (as % of service exports) in Macao?
Your answer should be compact. 5.06. In the year 2011, what is the difference between the Balance of Payment (as % of service exports) of Ethiopia and Balance of Payment (as % of service exports) of Romania?
Ensure brevity in your answer.  -29.03. In the year 2011, what is the difference between the Balance of Payment (as % of service exports) in Macao and Balance of Payment (as % of service exports) in Romania?
Provide a succinct answer. -34.09. In the year 2012, what is the difference between the Balance of Payment (as % of service exports) of Croatia and Balance of Payment (as % of service exports) of Ethiopia?
Provide a short and direct response. 7.58. In the year 2012, what is the difference between the Balance of Payment (as % of service exports) in Croatia and Balance of Payment (as % of service exports) in Macao?
Your response must be concise. 13.39. In the year 2012, what is the difference between the Balance of Payment (as % of service exports) of Croatia and Balance of Payment (as % of service exports) of Romania?
Offer a terse response. -23.21. In the year 2012, what is the difference between the Balance of Payment (as % of service exports) of Ethiopia and Balance of Payment (as % of service exports) of Macao?
Make the answer very short. 5.81. In the year 2012, what is the difference between the Balance of Payment (as % of service exports) in Ethiopia and Balance of Payment (as % of service exports) in Romania?
Make the answer very short. -30.79. In the year 2012, what is the difference between the Balance of Payment (as % of service exports) in Macao and Balance of Payment (as % of service exports) in Romania?
Keep it short and to the point. -36.6. What is the ratio of the Balance of Payment (as % of service exports) in Croatia in 2006 to that in 2007?
Provide a succinct answer. 1.06. What is the ratio of the Balance of Payment (as % of service exports) of Ethiopia in 2006 to that in 2007?
Your response must be concise. 0.72. What is the ratio of the Balance of Payment (as % of service exports) in Macao in 2006 to that in 2007?
Keep it short and to the point. 0.95. What is the ratio of the Balance of Payment (as % of service exports) of Romania in 2006 to that in 2007?
Your response must be concise. 0.77. What is the ratio of the Balance of Payment (as % of service exports) in Croatia in 2006 to that in 2008?
Your answer should be very brief. 1.05. What is the ratio of the Balance of Payment (as % of service exports) in Ethiopia in 2006 to that in 2008?
Provide a succinct answer. 1.06. What is the ratio of the Balance of Payment (as % of service exports) of Macao in 2006 to that in 2008?
Offer a terse response. 0.76. What is the ratio of the Balance of Payment (as % of service exports) of Romania in 2006 to that in 2008?
Your answer should be very brief. 0.73. What is the ratio of the Balance of Payment (as % of service exports) of Ethiopia in 2006 to that in 2009?
Keep it short and to the point. 0.84. What is the ratio of the Balance of Payment (as % of service exports) of Macao in 2006 to that in 2009?
Your answer should be very brief. 0.69. What is the ratio of the Balance of Payment (as % of service exports) of Romania in 2006 to that in 2009?
Your answer should be very brief. 0.63. What is the ratio of the Balance of Payment (as % of service exports) of Croatia in 2006 to that in 2010?
Your answer should be very brief. 0.85. What is the ratio of the Balance of Payment (as % of service exports) in Ethiopia in 2006 to that in 2010?
Your response must be concise. 0.79. What is the ratio of the Balance of Payment (as % of service exports) of Macao in 2006 to that in 2010?
Keep it short and to the point. 0.83. What is the ratio of the Balance of Payment (as % of service exports) in Romania in 2006 to that in 2010?
Your answer should be compact. 0.68. What is the ratio of the Balance of Payment (as % of service exports) in Croatia in 2006 to that in 2011?
Make the answer very short. 0.91. What is the ratio of the Balance of Payment (as % of service exports) of Ethiopia in 2006 to that in 2011?
Make the answer very short. 1.18. What is the ratio of the Balance of Payment (as % of service exports) in Macao in 2006 to that in 2011?
Your answer should be very brief. 0.8. What is the ratio of the Balance of Payment (as % of service exports) in Romania in 2006 to that in 2011?
Provide a succinct answer. 0.69. What is the ratio of the Balance of Payment (as % of service exports) in Croatia in 2006 to that in 2012?
Keep it short and to the point. 0.82. What is the ratio of the Balance of Payment (as % of service exports) in Ethiopia in 2006 to that in 2012?
Offer a very short reply. 1.09. What is the ratio of the Balance of Payment (as % of service exports) in Macao in 2006 to that in 2012?
Offer a terse response. 1.07. What is the ratio of the Balance of Payment (as % of service exports) of Romania in 2006 to that in 2012?
Keep it short and to the point. 0.64. What is the ratio of the Balance of Payment (as % of service exports) of Ethiopia in 2007 to that in 2008?
Your response must be concise. 1.47. What is the ratio of the Balance of Payment (as % of service exports) in Macao in 2007 to that in 2008?
Your answer should be compact. 0.79. What is the ratio of the Balance of Payment (as % of service exports) in Croatia in 2007 to that in 2009?
Ensure brevity in your answer.  0.91. What is the ratio of the Balance of Payment (as % of service exports) in Ethiopia in 2007 to that in 2009?
Ensure brevity in your answer.  1.17. What is the ratio of the Balance of Payment (as % of service exports) of Macao in 2007 to that in 2009?
Keep it short and to the point. 0.73. What is the ratio of the Balance of Payment (as % of service exports) of Romania in 2007 to that in 2009?
Provide a short and direct response. 0.82. What is the ratio of the Balance of Payment (as % of service exports) in Croatia in 2007 to that in 2010?
Your answer should be very brief. 0.8. What is the ratio of the Balance of Payment (as % of service exports) of Ethiopia in 2007 to that in 2010?
Ensure brevity in your answer.  1.1. What is the ratio of the Balance of Payment (as % of service exports) in Macao in 2007 to that in 2010?
Provide a short and direct response. 0.87. What is the ratio of the Balance of Payment (as % of service exports) of Romania in 2007 to that in 2010?
Offer a very short reply. 0.89. What is the ratio of the Balance of Payment (as % of service exports) of Croatia in 2007 to that in 2011?
Your answer should be compact. 0.86. What is the ratio of the Balance of Payment (as % of service exports) in Ethiopia in 2007 to that in 2011?
Your response must be concise. 1.64. What is the ratio of the Balance of Payment (as % of service exports) of Macao in 2007 to that in 2011?
Give a very brief answer. 0.83. What is the ratio of the Balance of Payment (as % of service exports) of Romania in 2007 to that in 2011?
Your response must be concise. 0.9. What is the ratio of the Balance of Payment (as % of service exports) of Croatia in 2007 to that in 2012?
Ensure brevity in your answer.  0.77. What is the ratio of the Balance of Payment (as % of service exports) of Ethiopia in 2007 to that in 2012?
Make the answer very short. 1.51. What is the ratio of the Balance of Payment (as % of service exports) in Macao in 2007 to that in 2012?
Offer a very short reply. 1.12. What is the ratio of the Balance of Payment (as % of service exports) of Romania in 2007 to that in 2012?
Offer a very short reply. 0.84. What is the ratio of the Balance of Payment (as % of service exports) of Croatia in 2008 to that in 2009?
Provide a succinct answer. 0.92. What is the ratio of the Balance of Payment (as % of service exports) in Ethiopia in 2008 to that in 2009?
Keep it short and to the point. 0.79. What is the ratio of the Balance of Payment (as % of service exports) in Macao in 2008 to that in 2009?
Offer a terse response. 0.92. What is the ratio of the Balance of Payment (as % of service exports) in Romania in 2008 to that in 2009?
Make the answer very short. 0.86. What is the ratio of the Balance of Payment (as % of service exports) in Croatia in 2008 to that in 2010?
Offer a terse response. 0.81. What is the ratio of the Balance of Payment (as % of service exports) of Ethiopia in 2008 to that in 2010?
Ensure brevity in your answer.  0.74. What is the ratio of the Balance of Payment (as % of service exports) in Macao in 2008 to that in 2010?
Keep it short and to the point. 1.1. What is the ratio of the Balance of Payment (as % of service exports) of Romania in 2008 to that in 2010?
Provide a short and direct response. 0.93. What is the ratio of the Balance of Payment (as % of service exports) in Croatia in 2008 to that in 2011?
Offer a very short reply. 0.86. What is the ratio of the Balance of Payment (as % of service exports) of Ethiopia in 2008 to that in 2011?
Keep it short and to the point. 1.12. What is the ratio of the Balance of Payment (as % of service exports) of Macao in 2008 to that in 2011?
Keep it short and to the point. 1.05. What is the ratio of the Balance of Payment (as % of service exports) in Romania in 2008 to that in 2011?
Provide a succinct answer. 0.93. What is the ratio of the Balance of Payment (as % of service exports) of Croatia in 2008 to that in 2012?
Your response must be concise. 0.78. What is the ratio of the Balance of Payment (as % of service exports) of Ethiopia in 2008 to that in 2012?
Make the answer very short. 1.03. What is the ratio of the Balance of Payment (as % of service exports) of Macao in 2008 to that in 2012?
Provide a succinct answer. 1.41. What is the ratio of the Balance of Payment (as % of service exports) in Romania in 2008 to that in 2012?
Keep it short and to the point. 0.88. What is the ratio of the Balance of Payment (as % of service exports) of Croatia in 2009 to that in 2010?
Ensure brevity in your answer.  0.89. What is the ratio of the Balance of Payment (as % of service exports) of Ethiopia in 2009 to that in 2010?
Give a very brief answer. 0.94. What is the ratio of the Balance of Payment (as % of service exports) of Macao in 2009 to that in 2010?
Make the answer very short. 1.2. What is the ratio of the Balance of Payment (as % of service exports) in Romania in 2009 to that in 2010?
Offer a very short reply. 1.09. What is the ratio of the Balance of Payment (as % of service exports) of Croatia in 2009 to that in 2011?
Offer a very short reply. 0.94. What is the ratio of the Balance of Payment (as % of service exports) of Ethiopia in 2009 to that in 2011?
Offer a very short reply. 1.4. What is the ratio of the Balance of Payment (as % of service exports) in Macao in 2009 to that in 2011?
Your response must be concise. 1.15. What is the ratio of the Balance of Payment (as % of service exports) of Romania in 2009 to that in 2011?
Offer a very short reply. 1.09. What is the ratio of the Balance of Payment (as % of service exports) in Croatia in 2009 to that in 2012?
Your answer should be very brief. 0.85. What is the ratio of the Balance of Payment (as % of service exports) in Ethiopia in 2009 to that in 2012?
Make the answer very short. 1.29. What is the ratio of the Balance of Payment (as % of service exports) of Macao in 2009 to that in 2012?
Give a very brief answer. 1.54. What is the ratio of the Balance of Payment (as % of service exports) in Romania in 2009 to that in 2012?
Your answer should be compact. 1.02. What is the ratio of the Balance of Payment (as % of service exports) in Croatia in 2010 to that in 2011?
Keep it short and to the point. 1.06. What is the ratio of the Balance of Payment (as % of service exports) of Ethiopia in 2010 to that in 2011?
Make the answer very short. 1.5. What is the ratio of the Balance of Payment (as % of service exports) of Macao in 2010 to that in 2011?
Ensure brevity in your answer.  0.95. What is the ratio of the Balance of Payment (as % of service exports) in Romania in 2010 to that in 2011?
Make the answer very short. 1. What is the ratio of the Balance of Payment (as % of service exports) of Croatia in 2010 to that in 2012?
Keep it short and to the point. 0.96. What is the ratio of the Balance of Payment (as % of service exports) of Ethiopia in 2010 to that in 2012?
Ensure brevity in your answer.  1.38. What is the ratio of the Balance of Payment (as % of service exports) in Macao in 2010 to that in 2012?
Offer a terse response. 1.28. What is the ratio of the Balance of Payment (as % of service exports) of Romania in 2010 to that in 2012?
Offer a terse response. 0.94. What is the ratio of the Balance of Payment (as % of service exports) in Croatia in 2011 to that in 2012?
Offer a very short reply. 0.9. What is the ratio of the Balance of Payment (as % of service exports) of Ethiopia in 2011 to that in 2012?
Your response must be concise. 0.92. What is the ratio of the Balance of Payment (as % of service exports) of Macao in 2011 to that in 2012?
Your response must be concise. 1.34. What is the ratio of the Balance of Payment (as % of service exports) of Romania in 2011 to that in 2012?
Make the answer very short. 0.94. What is the difference between the highest and the second highest Balance of Payment (as % of service exports) in Croatia?
Provide a short and direct response. 0.6. What is the difference between the highest and the second highest Balance of Payment (as % of service exports) of Ethiopia?
Give a very brief answer. 0.85. What is the difference between the highest and the second highest Balance of Payment (as % of service exports) of Macao?
Ensure brevity in your answer.  0.09. What is the difference between the highest and the second highest Balance of Payment (as % of service exports) in Romania?
Offer a very short reply. 0.92. What is the difference between the highest and the lowest Balance of Payment (as % of service exports) of Croatia?
Offer a terse response. 3.23. What is the difference between the highest and the lowest Balance of Payment (as % of service exports) in Ethiopia?
Provide a short and direct response. 3.83. What is the difference between the highest and the lowest Balance of Payment (as % of service exports) of Macao?
Offer a very short reply. 0.36. What is the difference between the highest and the lowest Balance of Payment (as % of service exports) in Romania?
Provide a short and direct response. 14.19. 